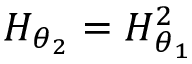<formula> <loc_0><loc_0><loc_500><loc_500>H _ { \boldsymbol \theta _ { 2 } } = H _ { \boldsymbol \theta _ { 1 } } ^ { 2 }</formula> 